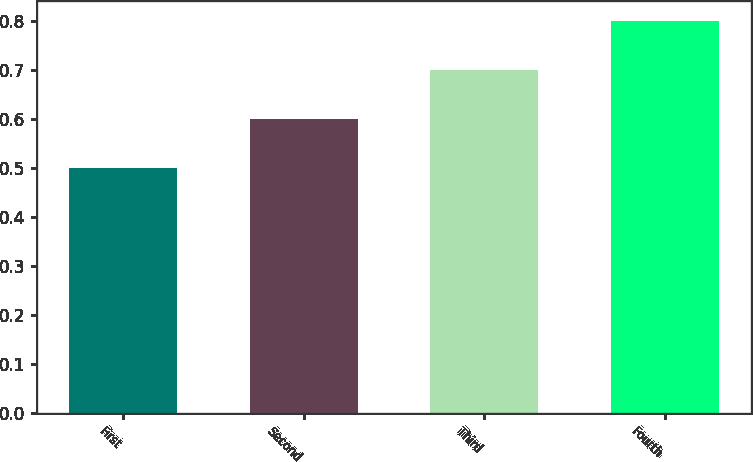Convert chart to OTSL. <chart><loc_0><loc_0><loc_500><loc_500><bar_chart><fcel>First<fcel>Second<fcel>Third<fcel>Fourth<nl><fcel>0.5<fcel>0.6<fcel>0.7<fcel>0.8<nl></chart> 